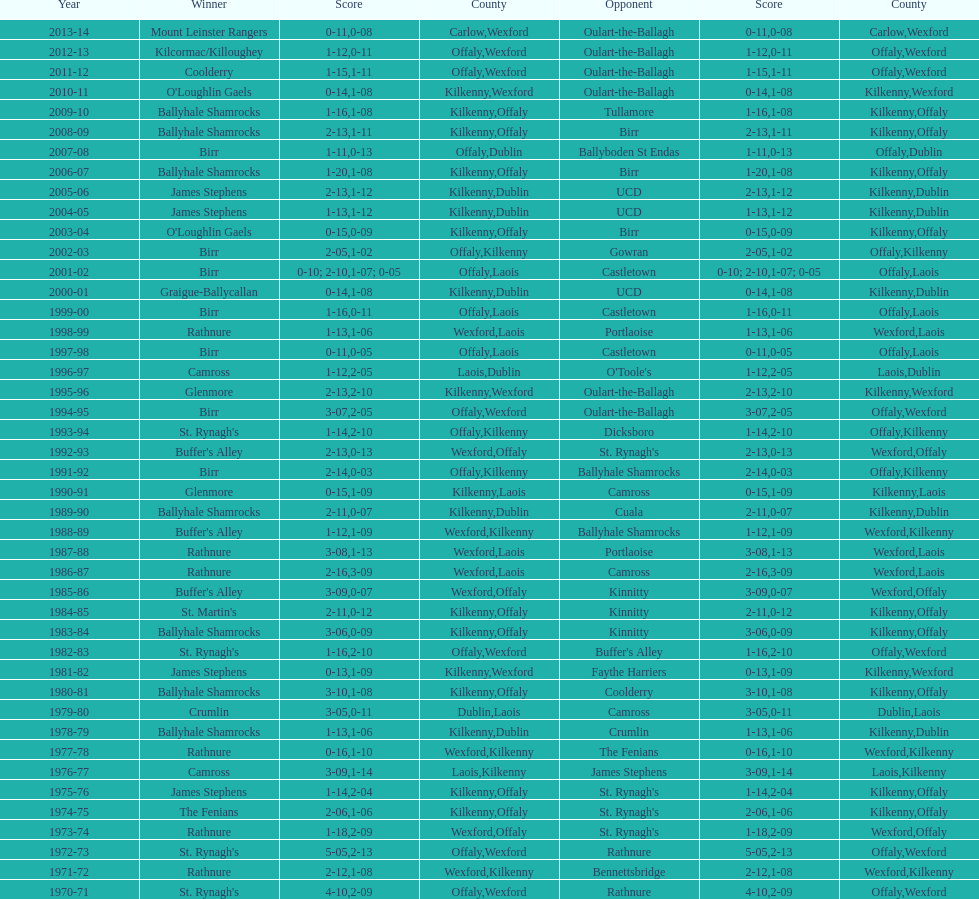James stephens won in 1976-76. who won three years before that? St. Rynagh's. 